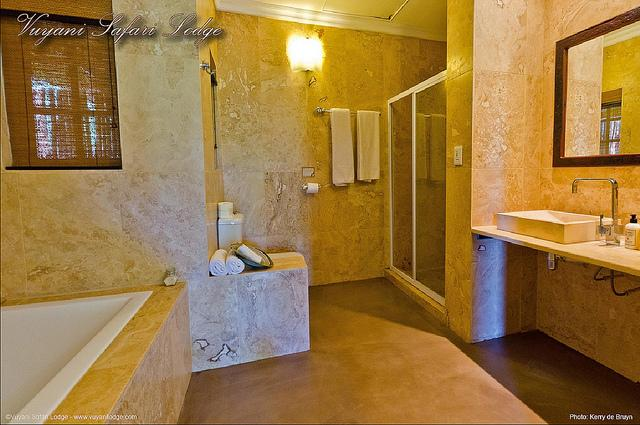What color is the lamp on the top of the wall next to the shower? white 